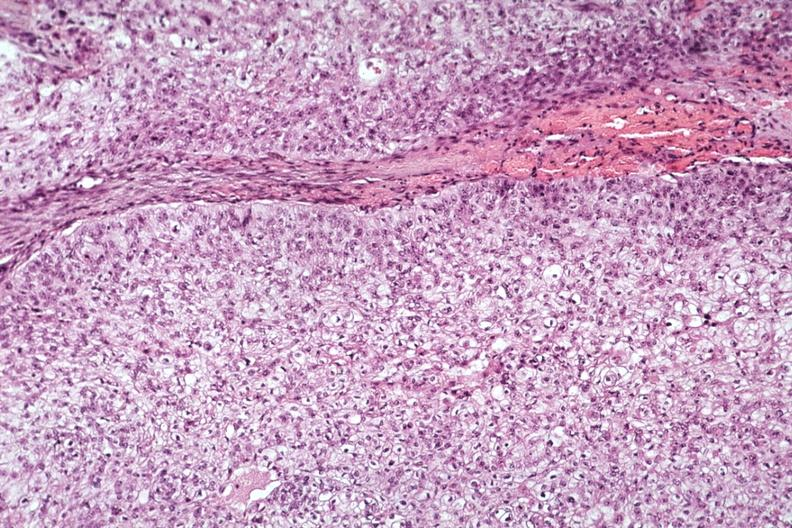what is present?
Answer the question using a single word or phrase. Mucoepidermoid carcinoma 